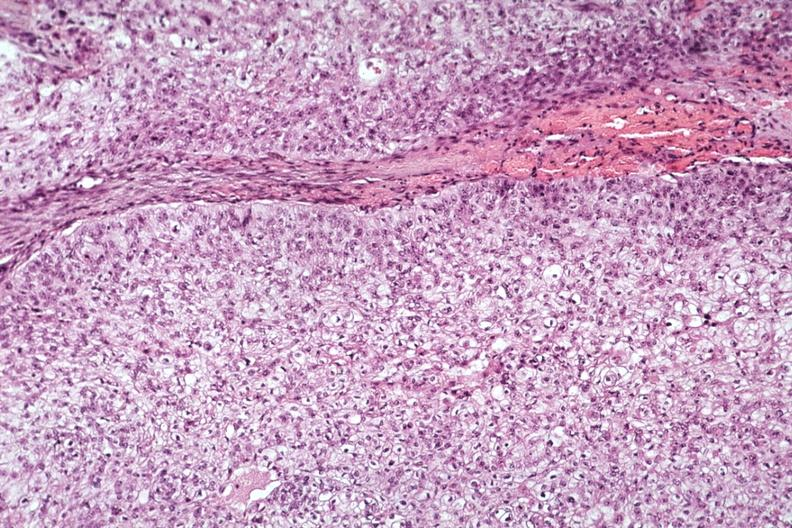what is present?
Answer the question using a single word or phrase. Mucoepidermoid carcinoma 